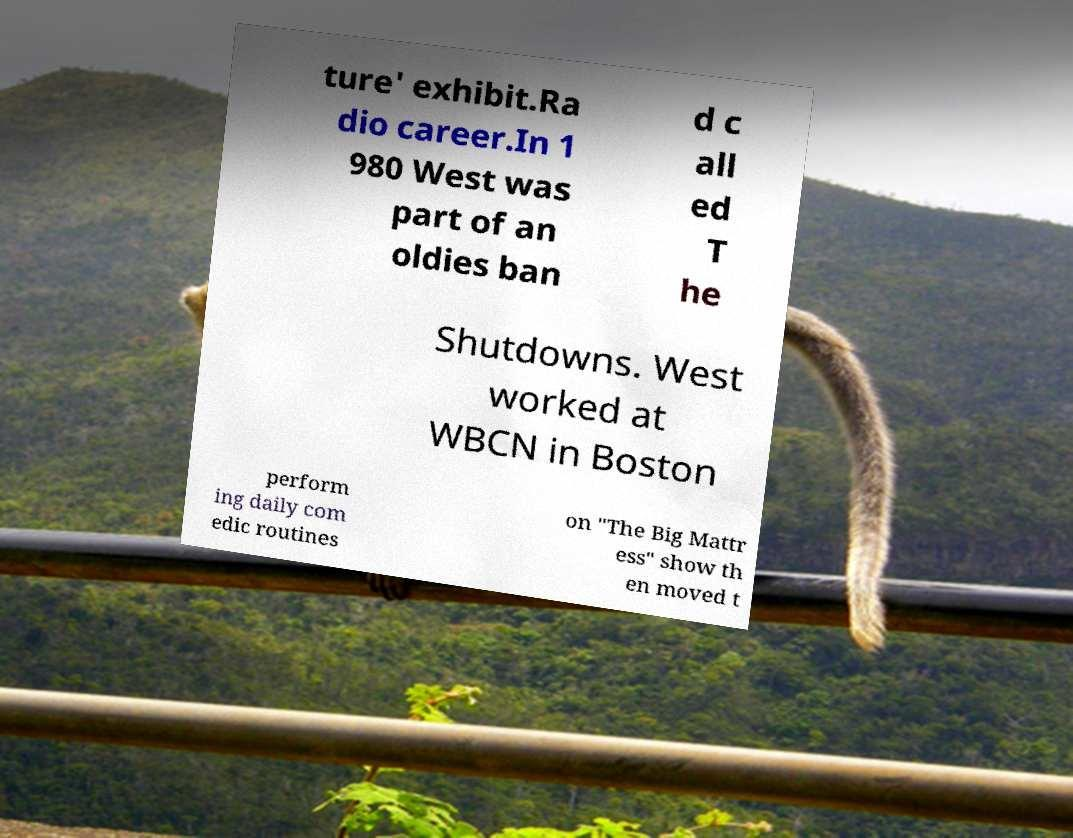There's text embedded in this image that I need extracted. Can you transcribe it verbatim? ture' exhibit.Ra dio career.In 1 980 West was part of an oldies ban d c all ed T he Shutdowns. West worked at WBCN in Boston perform ing daily com edic routines on "The Big Mattr ess" show th en moved t 